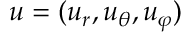Convert formula to latex. <formula><loc_0><loc_0><loc_500><loc_500>u = ( u _ { r } , u _ { \theta } , u _ { \varphi } )</formula> 